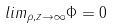Convert formula to latex. <formula><loc_0><loc_0><loc_500><loc_500>l i m _ { \rho , z \rightarrow \infty } \Phi = 0</formula> 